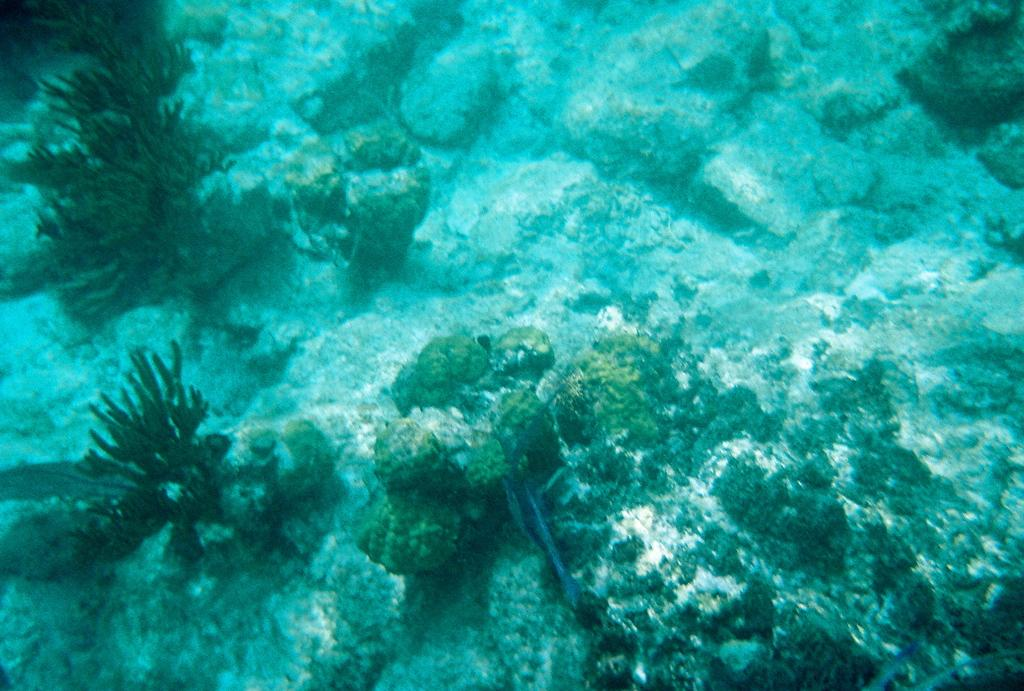What type of environment is depicted in the image? The image features water marines, which suggests a water-based environment. What other elements can be seen in the image? Water plants and stones are visible in the image. What type of soup is being served in the image? There is no soup present in the image; it features water marines, water plants, and stones. Can you see a tramp performing any tricks in the image? There is no tramp or any performance-related activities depicted in the image. 